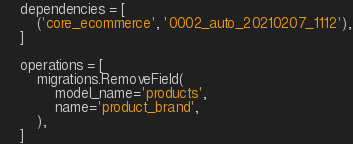<code> <loc_0><loc_0><loc_500><loc_500><_Python_>    dependencies = [
        ('core_ecommerce', '0002_auto_20210207_1112'),
    ]

    operations = [
        migrations.RemoveField(
            model_name='products',
            name='product_brand',
        ),
    ]
</code> 